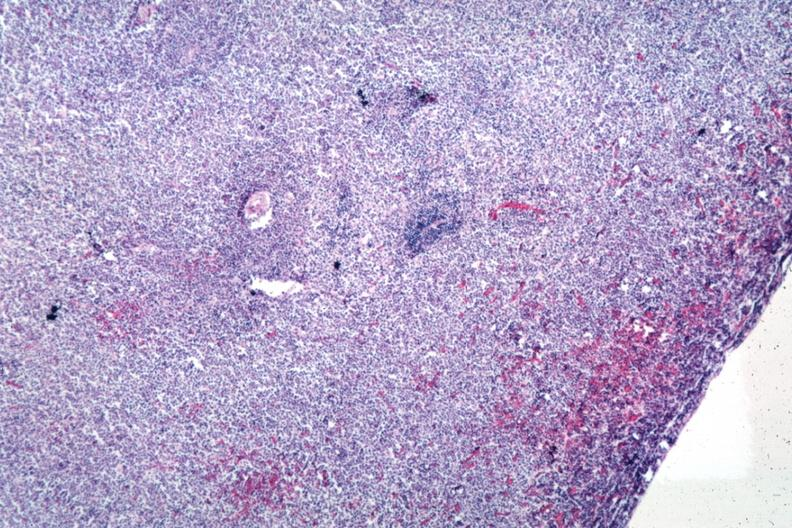what is present?
Answer the question using a single word or phrase. Spleen 